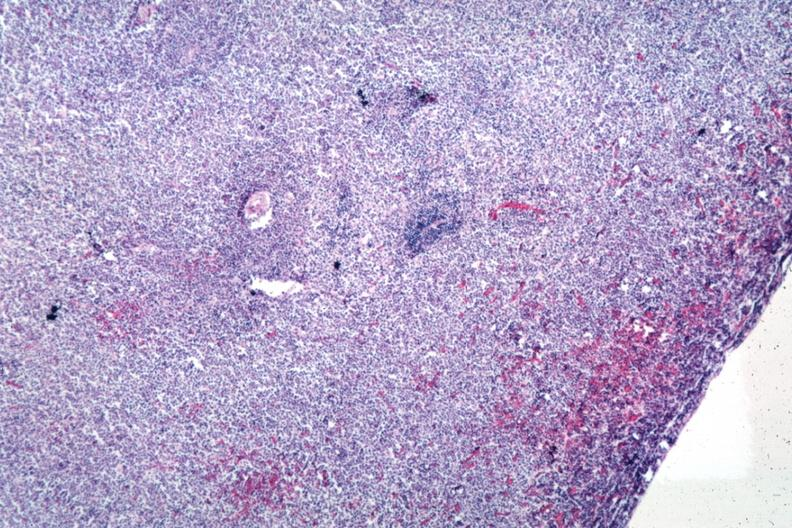what is present?
Answer the question using a single word or phrase. Spleen 